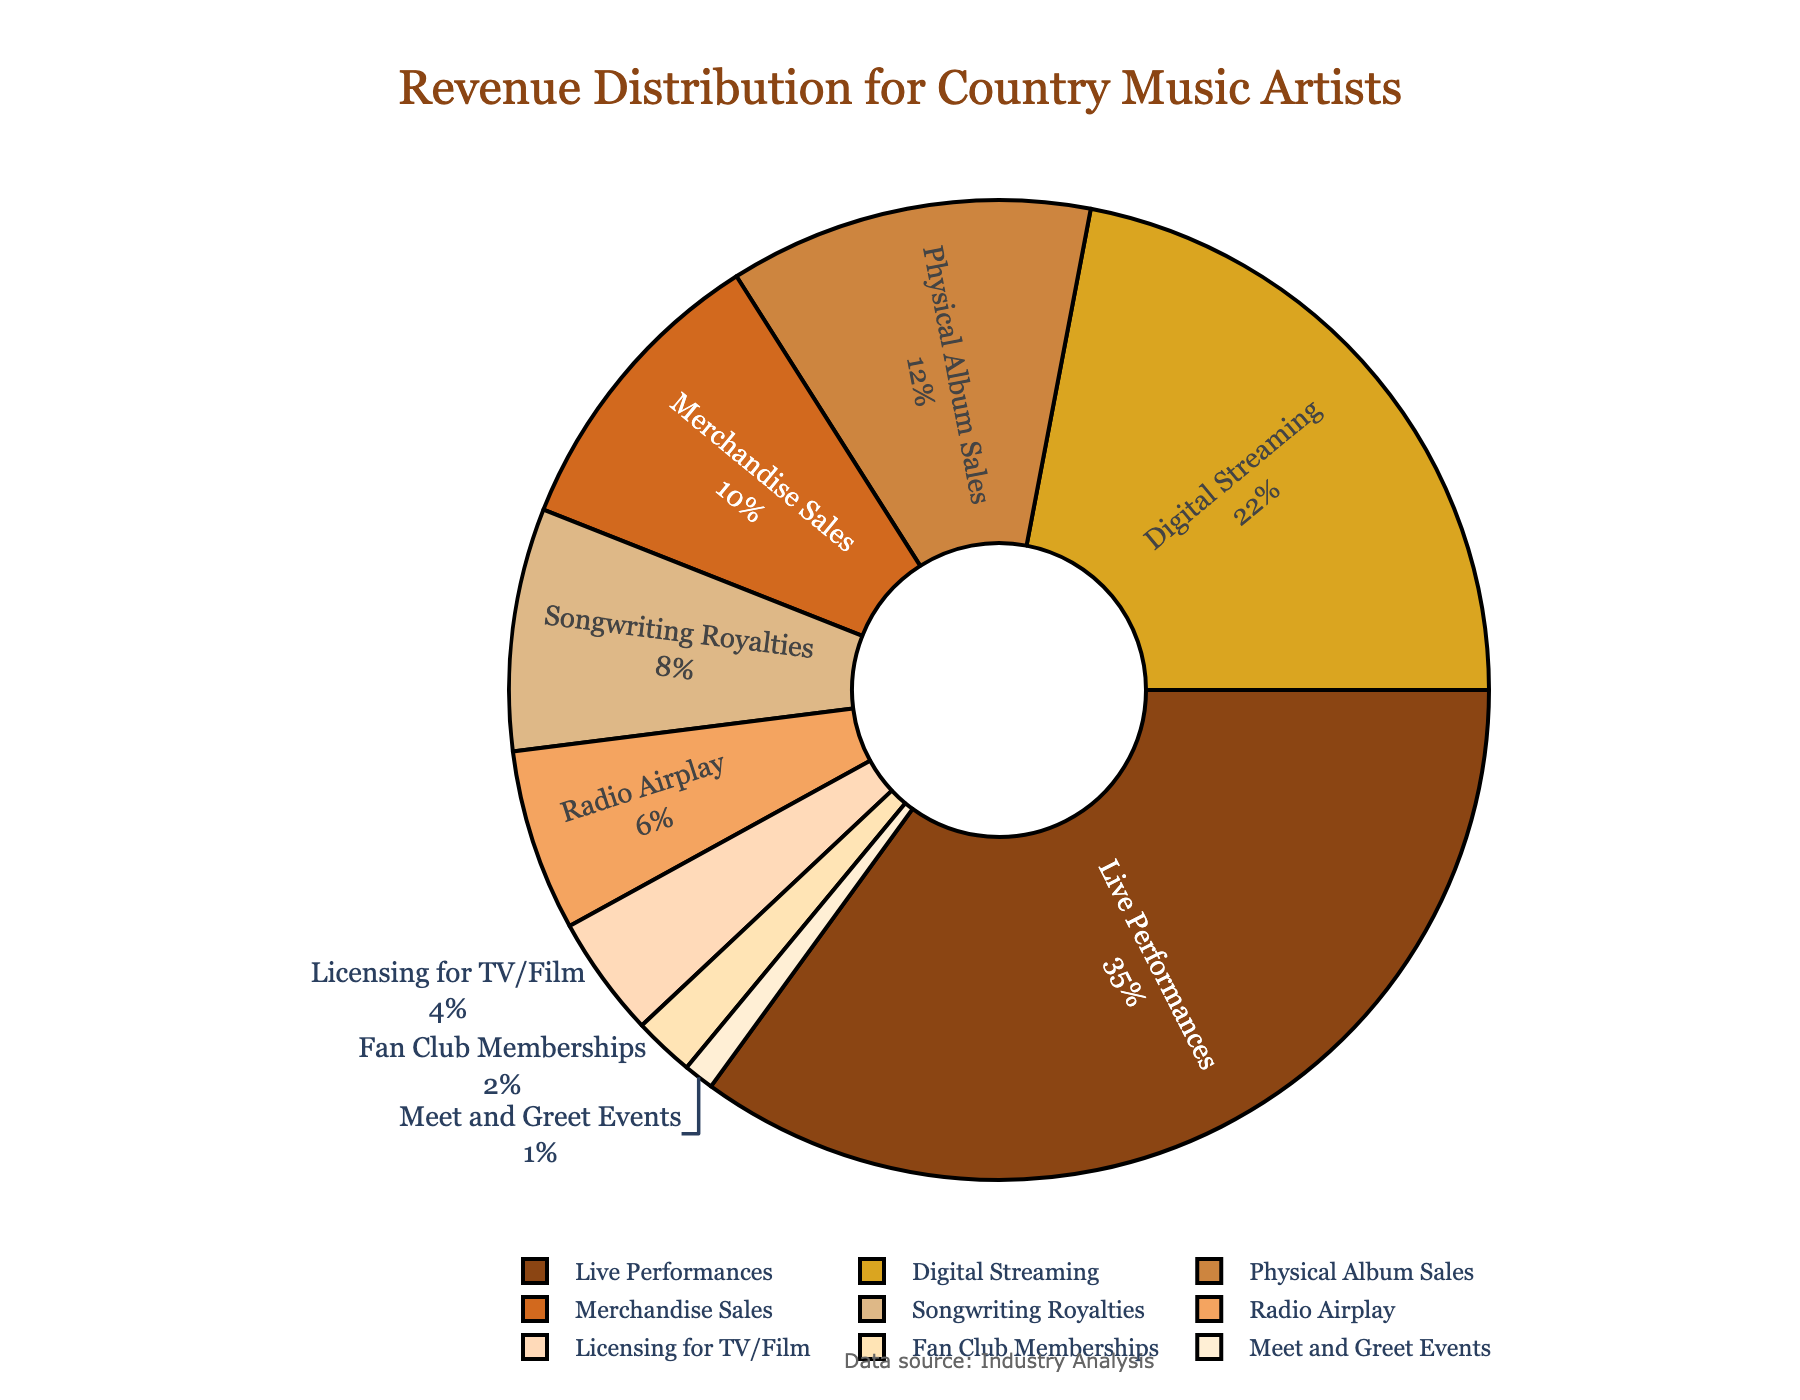What percentage of the total revenue comes from Live Performances and Digital Streaming combined? To find the combined percentage, add the percentages of Live Performances (35%) and Digital Streaming (22%). The calculation is 35 + 22 = 57.
Answer: 57% Which income stream contributes the least to the total revenue? Identify the smallest percentage in the pie chart, which belongs to Meet and Greet Events at 1%.
Answer: Meet and Greet Events How much more revenue percentage does Live Performances generate compared to Physical Album Sales? Subtract the percentage of Physical Album Sales (12%) from the percentage of Live Performances (35%). The calculation is 35 - 12 = 23.
Answer: 23% Are the combined percentages of Physical Album Sales and Merchandise Sales greater than Digital Streaming? Add the percentages of Physical Album Sales (12%) and Merchandise Sales (10%), then compare the sum to Digital Streaming (22%). The calculation is 12 + 10 = 22, which is equal to 22.
Answer: No How does the revenue from Songwriting Royalties compare to Radio Airplay? Compare the percentages directly; Songwriting Royalties is at 8%, and Radio Airplay is at 6%. Since 8 is greater than 6, Songwriting Royalties generates more revenue.
Answer: Songwriting Royalties What is the total percentage of revenue derived from sources other than Live Performances, Digital Streaming, and Physical Album Sales? Add all the percentages and subtract the percentages of Live Performances (35%), Digital Streaming (22%), and Physical Album Sales (12%). The calculation is 100 - (35 + 22 + 12) = 100 - 69 = 31.
Answer: 31% Which income stream has a larger revenue percentage: Licensing for TV/Film or Fan Club Memberships? Compare the percentages directly: Licensing for TV/Film is at 4%, and Fan Club Memberships are at 2%. Since 4 is greater than 2, Licensing for TV/Film has a larger revenue percentage.
Answer: Licensing for TV/Film What is the difference in percentage between the revenue from Merchandise Sales and Radio Airplay? Subtract the percentage of Radio Airplay (6%) from Merchandise Sales (10%). The calculation is 10 - 6 = 4.
Answer: 4% What percentage of revenue is generated by Songwriting Royalties and Licensing for TV/Film combined? Add the percentages of Songwriting Royalties (8%) and Licensing for TV/Film (4%). The calculation is 8 + 4 = 12.
Answer: 12% Between Live Performances and Digital Streaming, which income stream generates a higher percentage of revenue, and by how much? Compare the percentages directly and find the difference: Live Performances (35%) and Digital Streaming (22%). The calculation is 35 - 22 = 13.
Answer: Live Performances, by 13% 